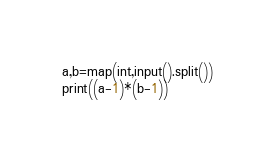<code> <loc_0><loc_0><loc_500><loc_500><_Python_>a,b=map(int,input().split())
print((a-1)*(b-1))
</code> 